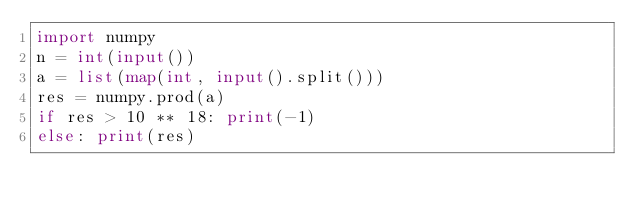Convert code to text. <code><loc_0><loc_0><loc_500><loc_500><_Python_>import numpy
n = int(input())
a = list(map(int, input().split()))
res = numpy.prod(a)
if res > 10 ** 18: print(-1)
else: print(res)</code> 